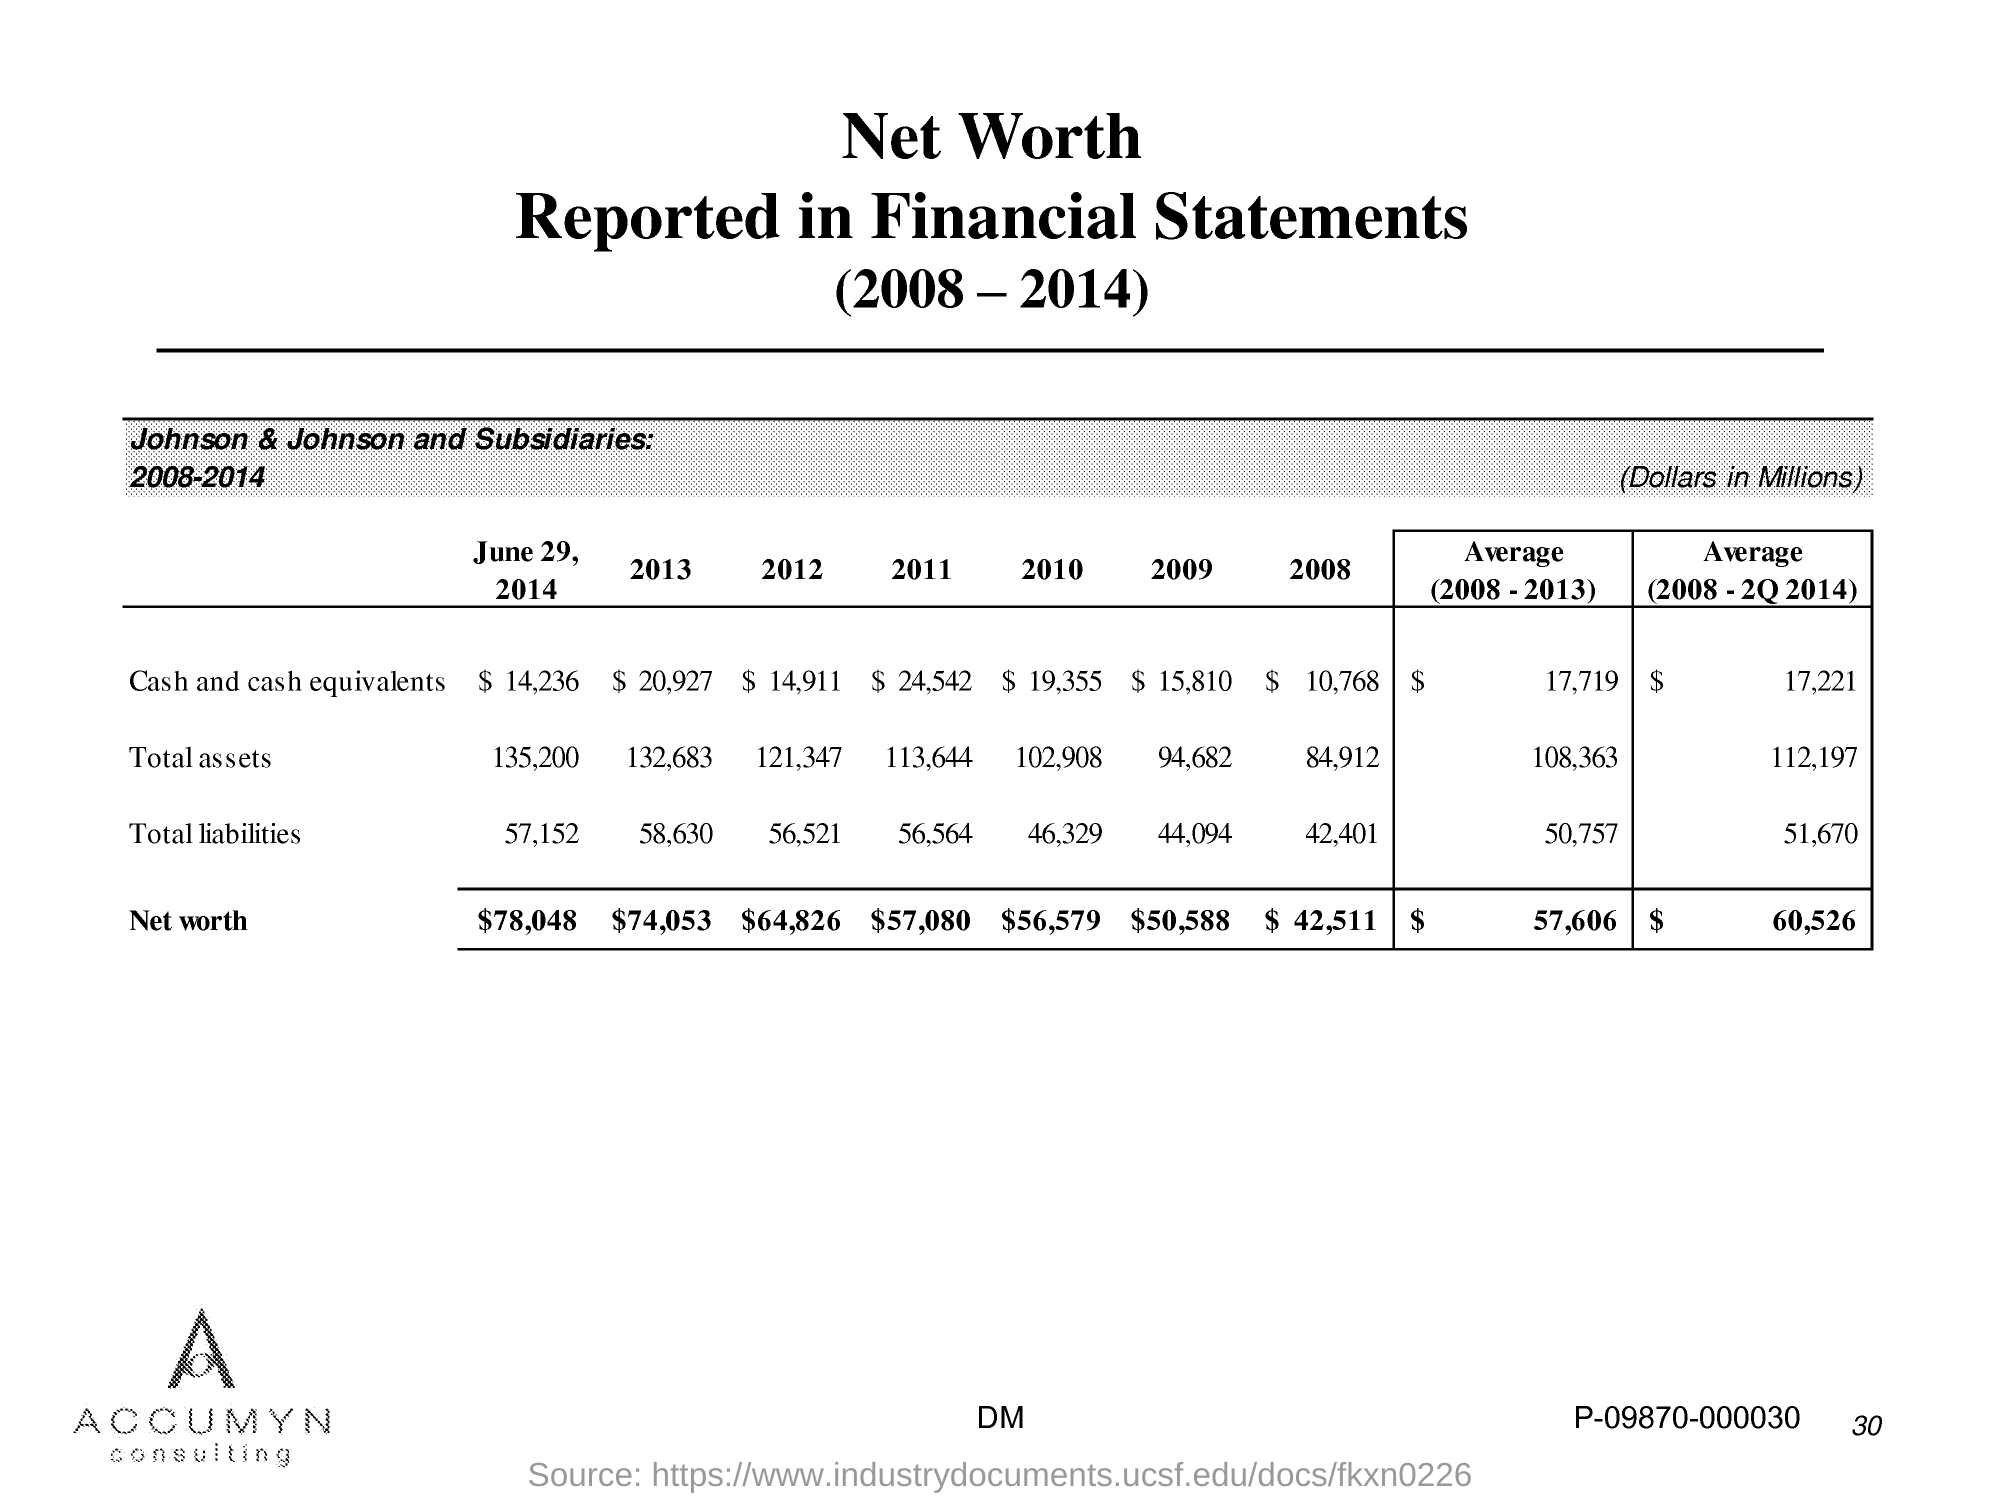Please tell me how the net worth of Johnson & Johnson has changed over the years according to this financial statement. The net worth of Johnson & Johnson has shown an overall increase from 2008 to 2014. Starting at $42,511 million in 2008, it experienced some fluctuations but generally trended upwards, reaching $57,080 million in 2011, and peaking at $78,048 million in 2014. 